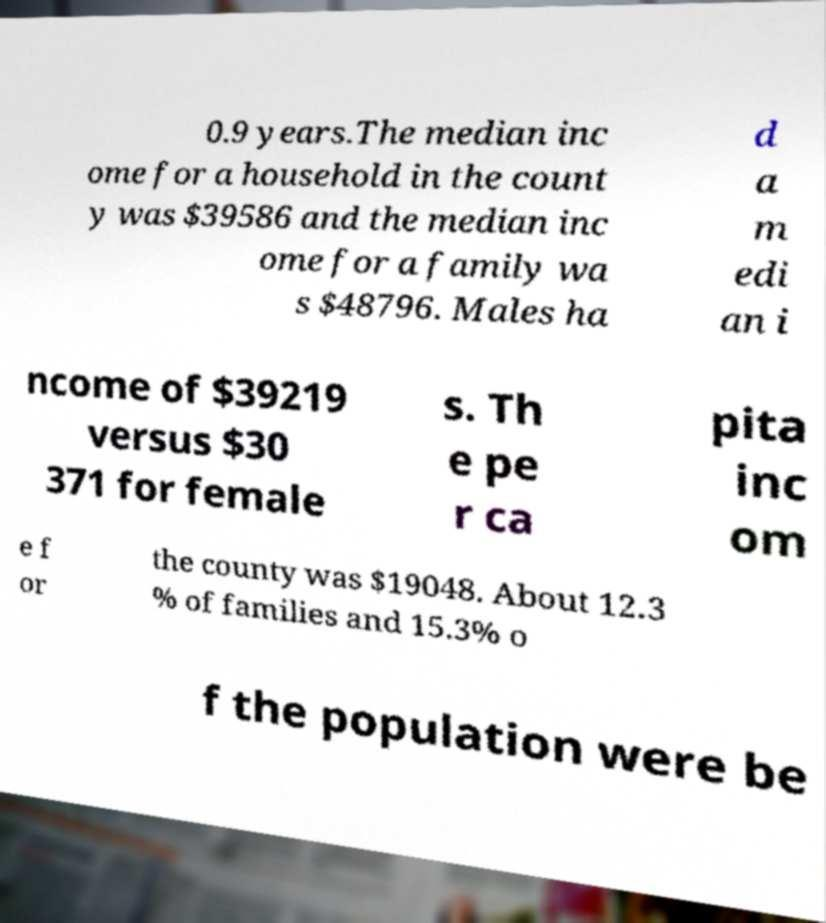I need the written content from this picture converted into text. Can you do that? 0.9 years.The median inc ome for a household in the count y was $39586 and the median inc ome for a family wa s $48796. Males ha d a m edi an i ncome of $39219 versus $30 371 for female s. Th e pe r ca pita inc om e f or the county was $19048. About 12.3 % of families and 15.3% o f the population were be 